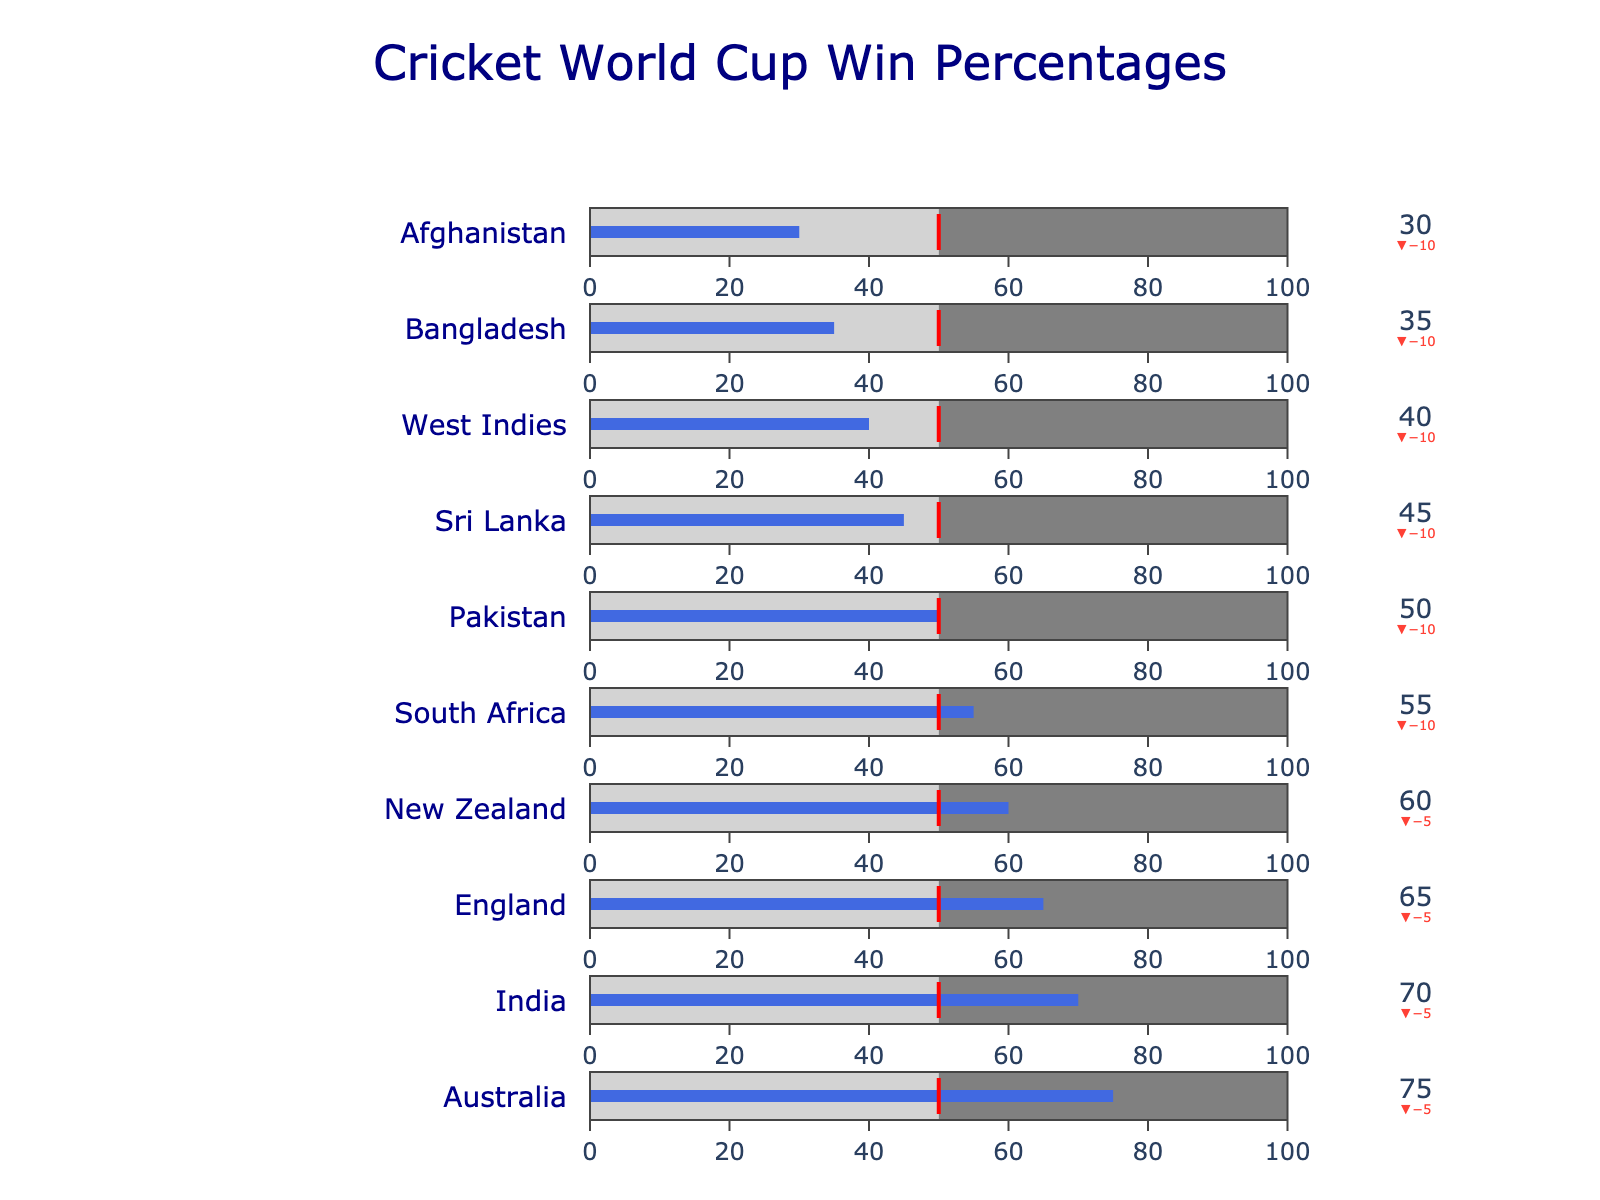what is the highest Actual Win Percentage? The highest Actual Win % is 75%, as indicated by Australia's position at the top of the chart.
Answer: 75% What is the difference between Australia’s Actual Win % and its Target Win %? Australia's Actual Win % is 75%, and its Target Win % is 80%. The difference can be calculated as 80% - 75%.
Answer: 5% How does England’s Actual Win % compare to the World Average Win %? England's Actual Win % is 65%, while the World Average Win % is 50%. England’s Actual Win % is 15% higher than the World Average Win %.
Answer: 15% higher Which country has an Actual Win % equal to the World Average Win %? The country with an Actual Win % equal to the World Average Win % (50%) is Pakistan.
Answer: Pakistan How many countries have an Actual Win % above the world average? The countries with Actual Win % above 50% are Australia, India, England, New Zealand, and South Africa. A total of 5 countries meet this criterion.
Answer: 5 What is the combined Actual Win % of New Zealand and South Africa? New Zealand's Actual Win % is 60%, and South Africa's is 55%. The combined Actual Win % can be calculated as 60% + 55%.
Answer: 115% Which country has the biggest gap between its Actual Win % and Target Win %? Sri Lanka has an Actual Win % of 45% and a Target Win % of 55%, creating a gap of 10%. This is the biggest gap among all countries.
Answer: Sri Lanka Is there any country performing better than its Target Win %? No country is performing better than its Target Win %, as all Actual Win % values are less than their respective Target Win % values.
Answer: No 